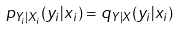Convert formula to latex. <formula><loc_0><loc_0><loc_500><loc_500>p _ { Y _ { i } | X _ { i } } ( y _ { i } | x _ { i } ) = q _ { Y | X } ( y _ { i } | x _ { i } )</formula> 